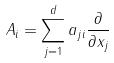<formula> <loc_0><loc_0><loc_500><loc_500>A _ { i } = \sum _ { j = 1 } ^ { d } a _ { j i } \frac { \partial } { \partial x _ { j } }</formula> 